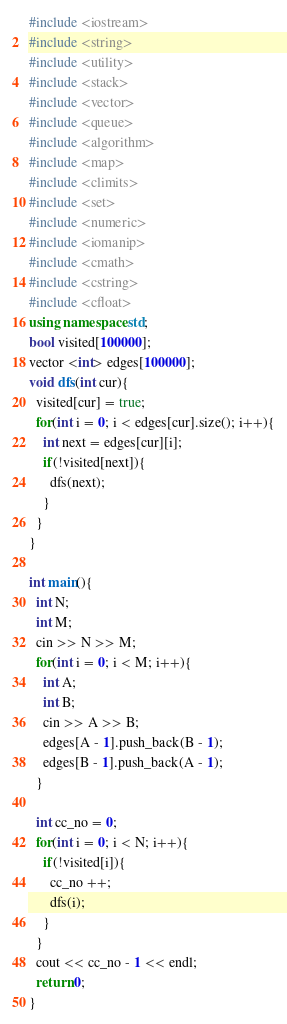Convert code to text. <code><loc_0><loc_0><loc_500><loc_500><_C++_>#include <iostream>
#include <string>
#include <utility>
#include <stack>
#include <vector>
#include <queue>
#include <algorithm>
#include <map>
#include <climits>
#include <set>
#include <numeric>
#include <iomanip>
#include <cmath>
#include <cstring>
#include <cfloat>
using namespace std;
bool visited[100000];
vector <int> edges[100000];
void dfs(int cur){
  visited[cur] = true;
  for(int i = 0; i < edges[cur].size(); i++){
    int next = edges[cur][i];
    if(!visited[next]){
      dfs(next);
    }
  }
}

int main(){
  int N;
  int M;
  cin >> N >> M;
  for(int i = 0; i < M; i++){
    int A;
    int B;
    cin >> A >> B;
    edges[A - 1].push_back(B - 1);
    edges[B - 1].push_back(A - 1);
  }

  int cc_no = 0;
  for(int i = 0; i < N; i++){
    if(!visited[i]){
      cc_no ++;
      dfs(i);
    }
  }
  cout << cc_no - 1 << endl;
  return 0;
}
</code> 